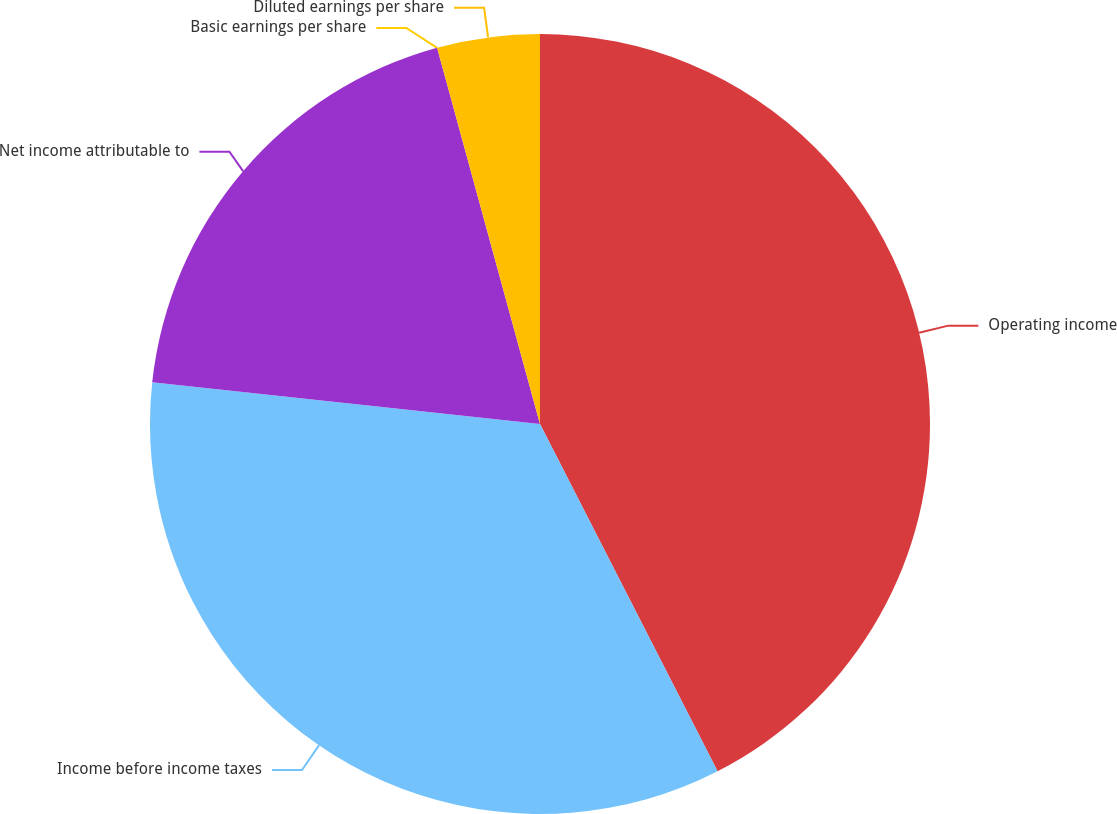<chart> <loc_0><loc_0><loc_500><loc_500><pie_chart><fcel>Operating income<fcel>Income before income taxes<fcel>Net income attributable to<fcel>Basic earnings per share<fcel>Diluted earnings per share<nl><fcel>42.48%<fcel>34.23%<fcel>19.05%<fcel>0.0%<fcel>4.25%<nl></chart> 